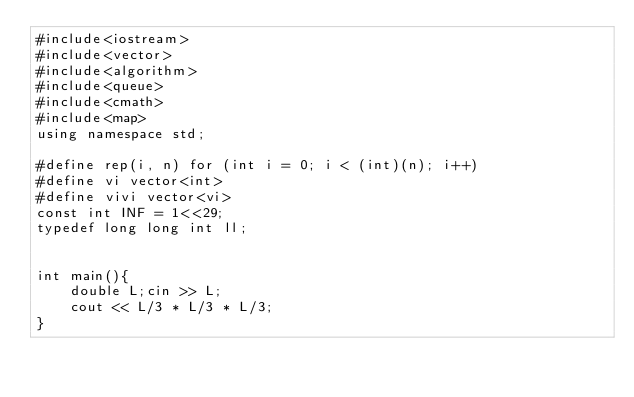Convert code to text. <code><loc_0><loc_0><loc_500><loc_500><_C++_>#include<iostream>
#include<vector>
#include<algorithm>
#include<queue>
#include<cmath>
#include<map>
using namespace std;

#define rep(i, n) for (int i = 0; i < (int)(n); i++)
#define vi vector<int>
#define vivi vector<vi>
const int INF = 1<<29;
typedef long long int ll;


int main(){
    double L;cin >> L;
    cout << L/3 * L/3 * L/3;
}
</code> 